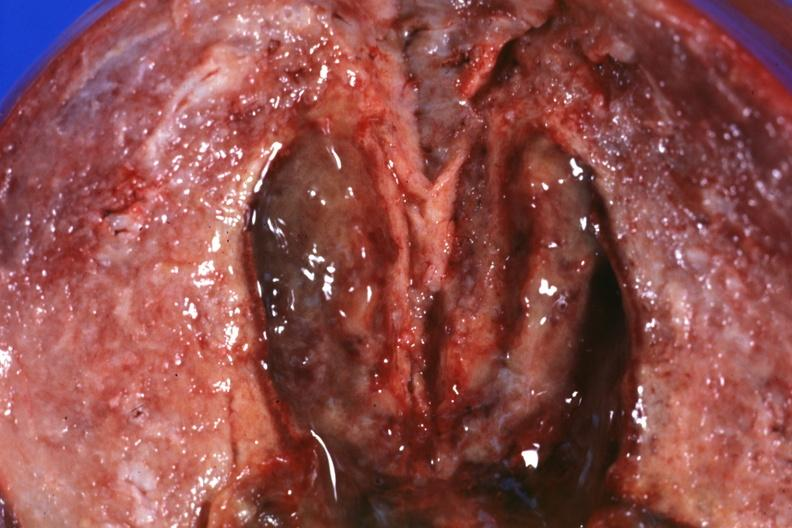what does this image show?
Answer the question using a single word or phrase. Close-up view of 5 weeks post section 29yobf hypertension and brain hemorrhage 